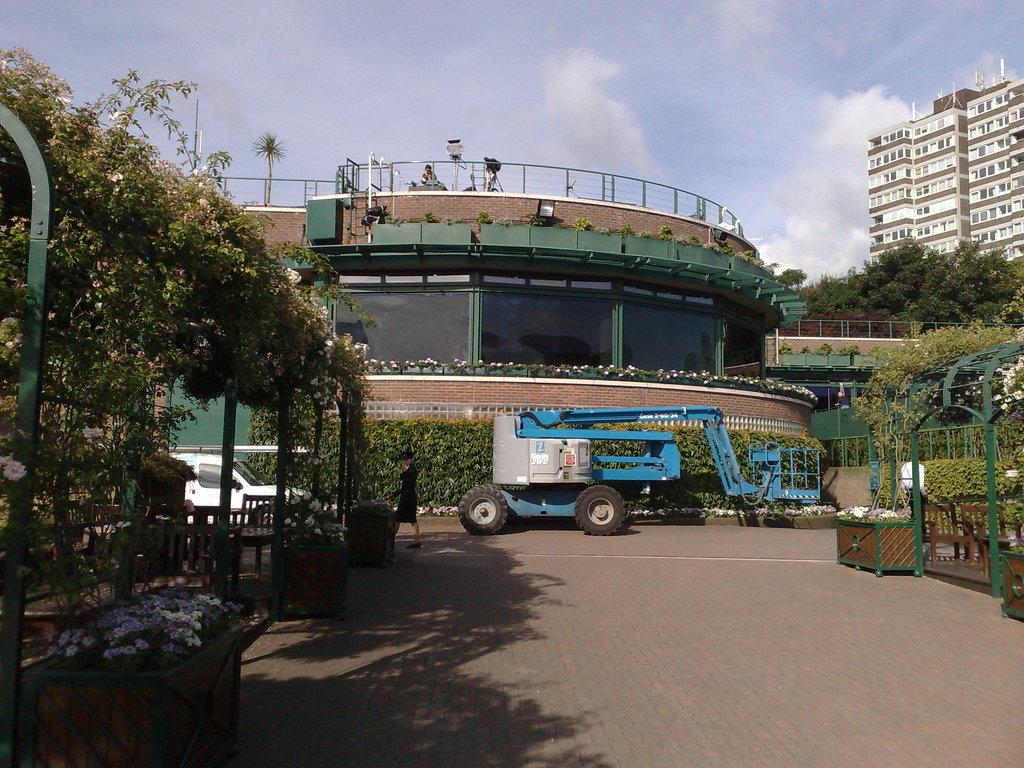What is the lady in the image doing? The lady in the image is walking. On what surface is the lady walking? The lady is walking on the pavement. What can be seen behind the lady in the image? There are two trucks behind the lady. What is visible in the background of the image? There are trees and buildings in the background of the image. What type of wrench is the lady holding in the image? There is no wrench present in the image; the lady is simply walking. What committee is responsible for the maintenance of the pavement in the image? There is no information about a committee in the image, as it only shows a lady walking on the pavement. 